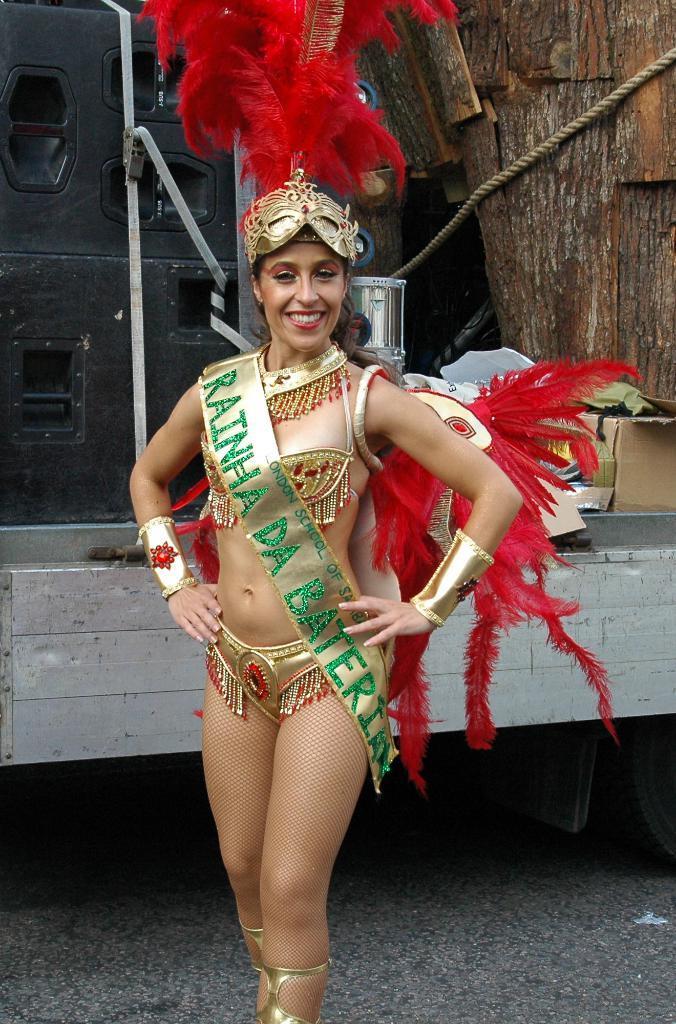Please provide a concise description of this image. In this image I can see a woman standing in the center of the image and posing for the picture, she is wearing a banner with some text. I can see a wooden construction behind her. 